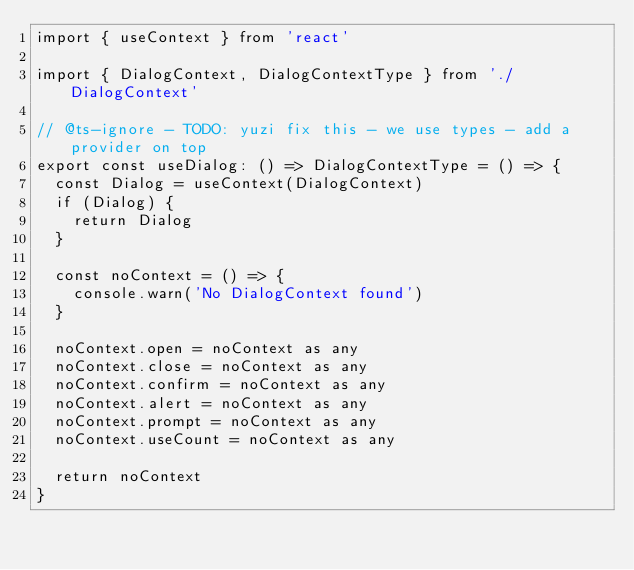<code> <loc_0><loc_0><loc_500><loc_500><_TypeScript_>import { useContext } from 'react'

import { DialogContext, DialogContextType } from './DialogContext'

// @ts-ignore - TODO: yuzi fix this - we use types - add a provider on top
export const useDialog: () => DialogContextType = () => {
  const Dialog = useContext(DialogContext)
  if (Dialog) {
    return Dialog
  }

  const noContext = () => {
    console.warn('No DialogContext found')
  }

  noContext.open = noContext as any
  noContext.close = noContext as any
  noContext.confirm = noContext as any
  noContext.alert = noContext as any
  noContext.prompt = noContext as any
  noContext.useCount = noContext as any

  return noContext
}
</code> 